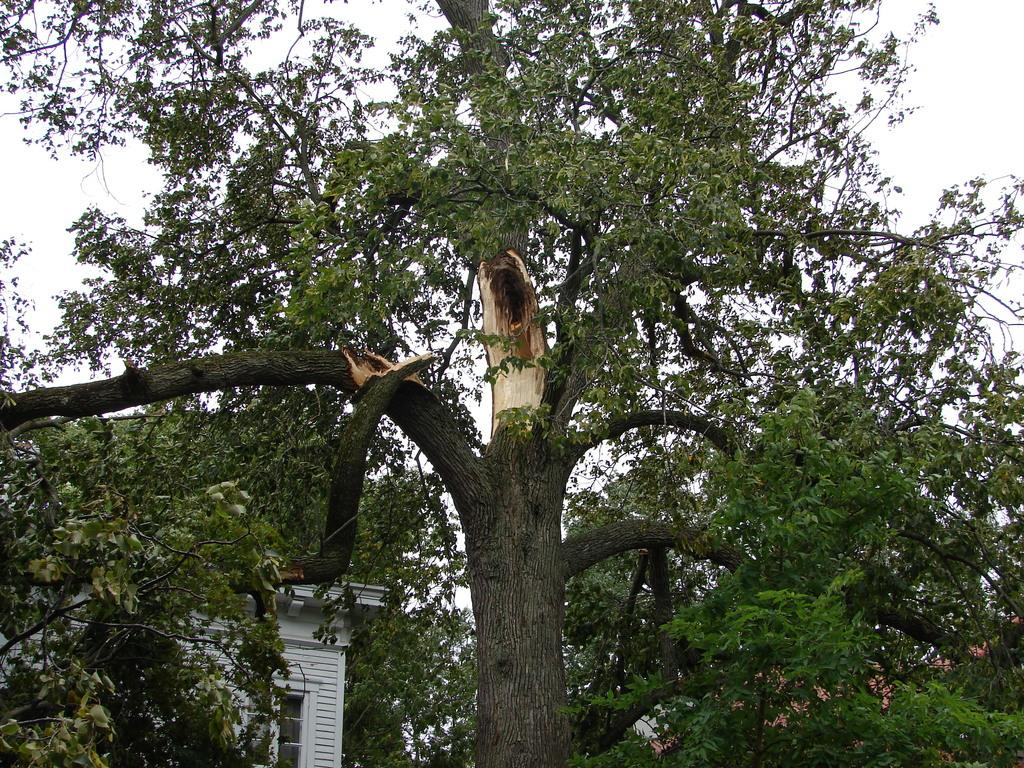What is located in the foreground of the image? There is a tree in the foreground of the image. What can be seen in the background of the image? There are houses and additional trees in the background of the image. How many feet of wax can be seen on the tree in the image? There is no wax present on the tree in the image. 